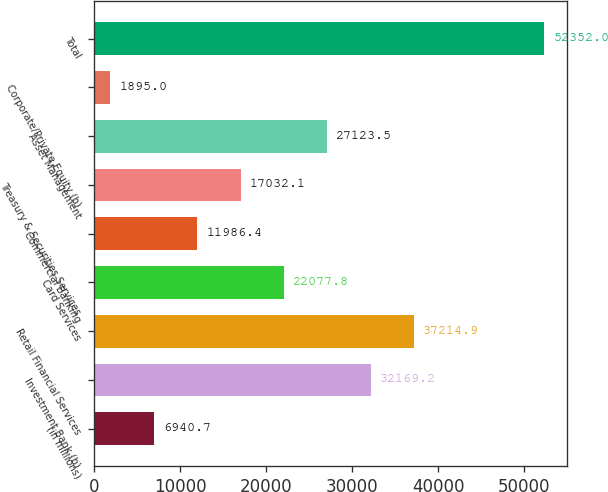<chart> <loc_0><loc_0><loc_500><loc_500><bar_chart><fcel>(in millions)<fcel>Investment Bank (b)<fcel>Retail Financial Services<fcel>Card Services<fcel>Commercial Banking<fcel>Treasury & Securities Services<fcel>Asset Management<fcel>Corporate/Private Equity (b)<fcel>Total<nl><fcel>6940.7<fcel>32169.2<fcel>37214.9<fcel>22077.8<fcel>11986.4<fcel>17032.1<fcel>27123.5<fcel>1895<fcel>52352<nl></chart> 